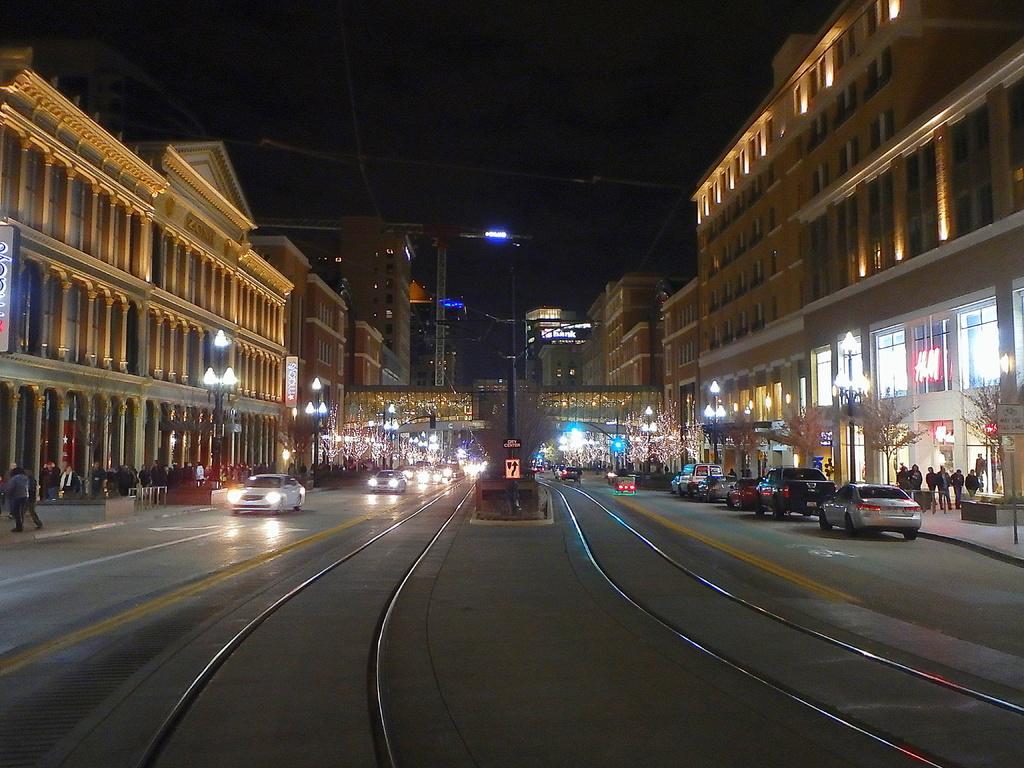Could you give a brief overview of what you see in this image? In this image we can see buildings, street poles, street lights, trees, motor vehicles on the road, person's standing on the road and sky. 